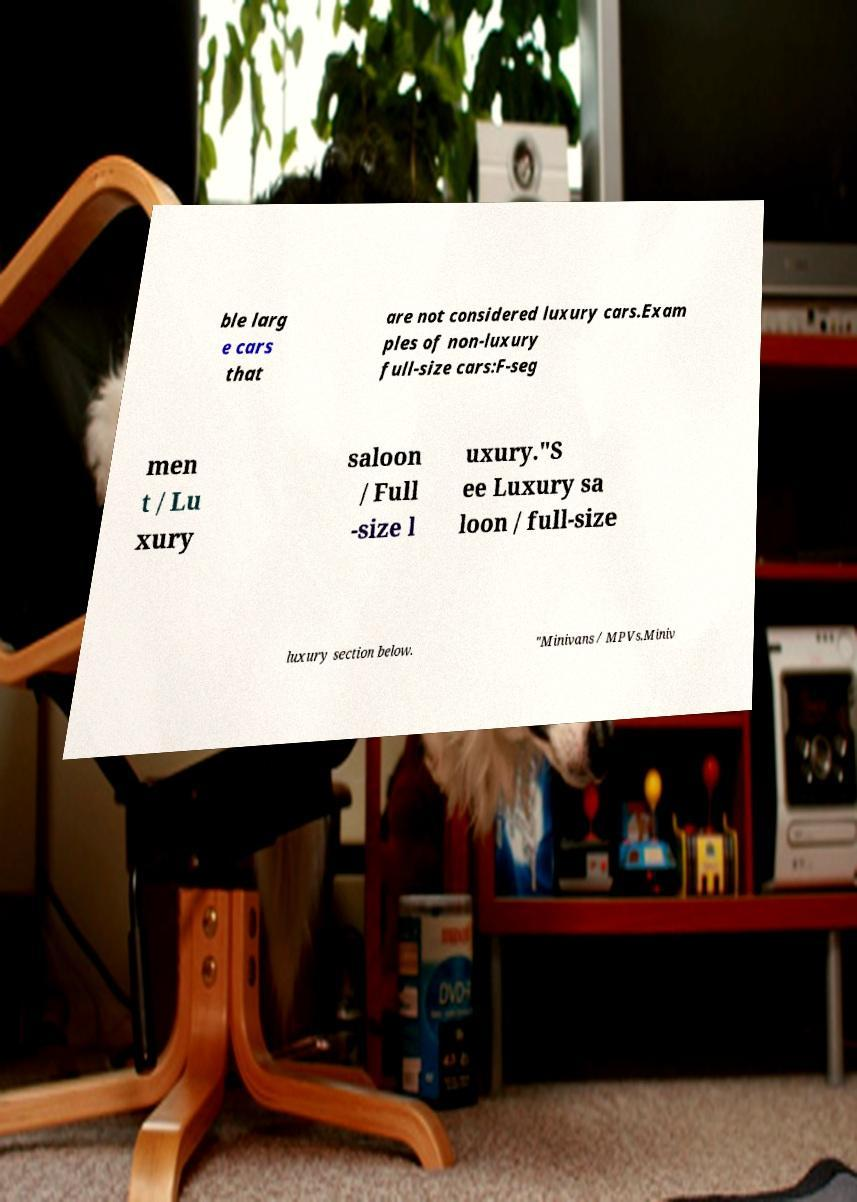Can you read and provide the text displayed in the image?This photo seems to have some interesting text. Can you extract and type it out for me? ble larg e cars that are not considered luxury cars.Exam ples of non-luxury full-size cars:F-seg men t / Lu xury saloon / Full -size l uxury."S ee Luxury sa loon / full-size luxury section below. "Minivans / MPVs.Miniv 